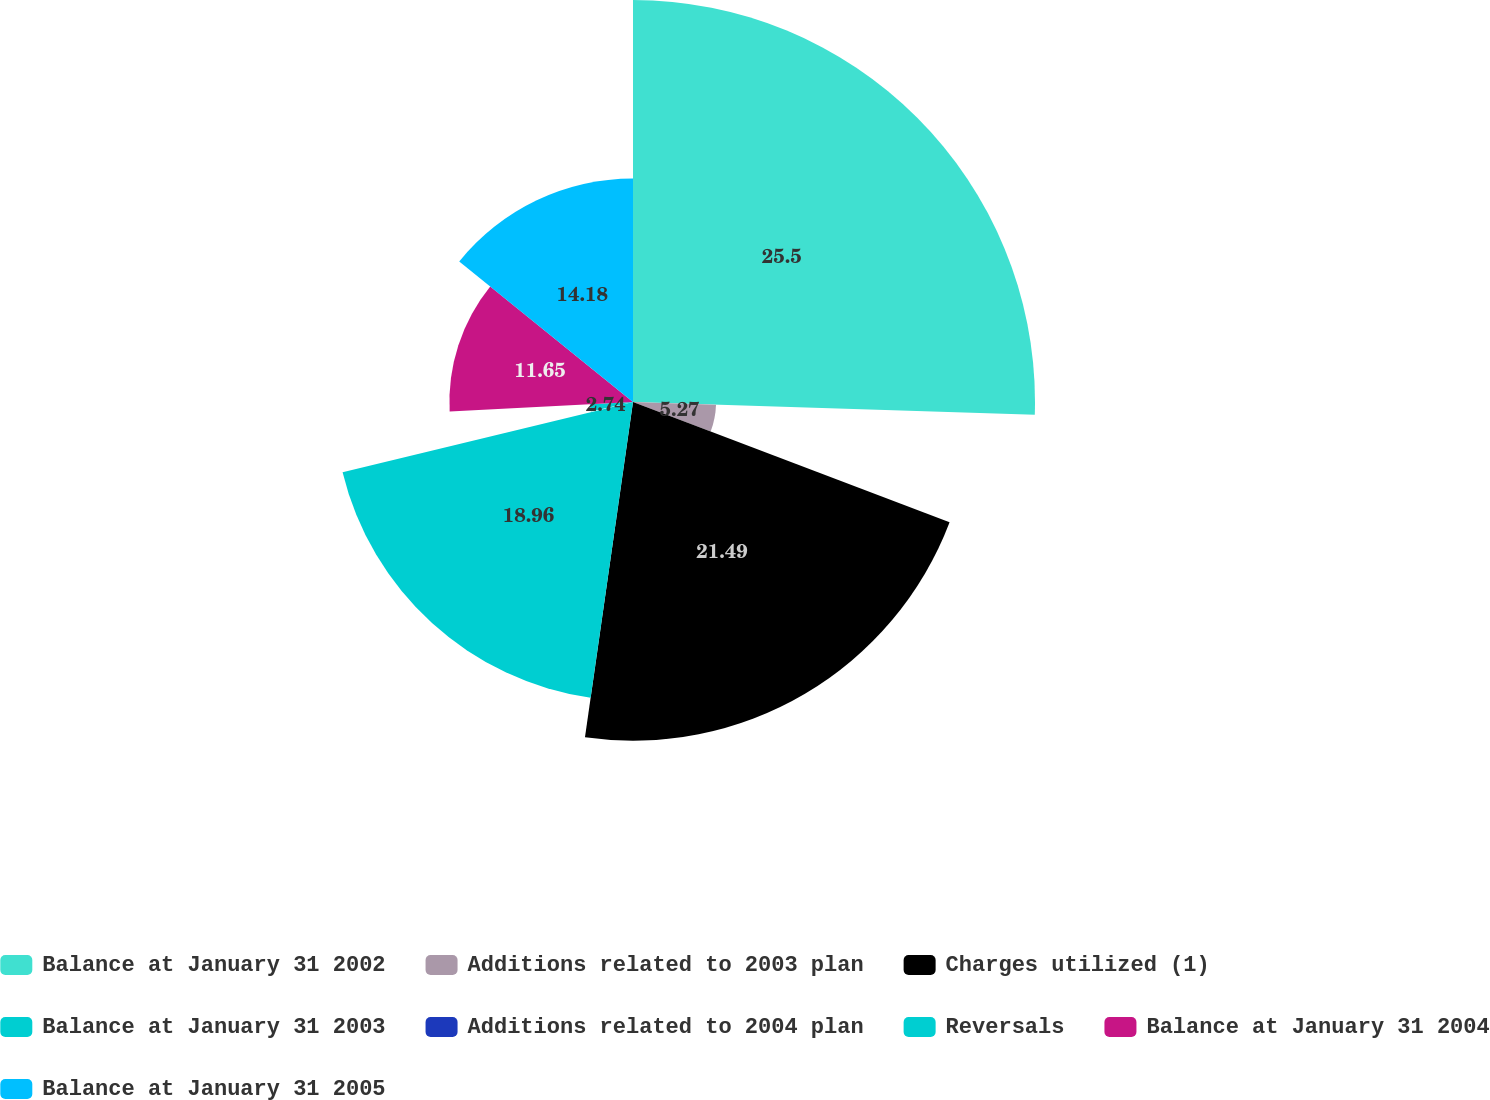<chart> <loc_0><loc_0><loc_500><loc_500><pie_chart><fcel>Balance at January 31 2002<fcel>Additions related to 2003 plan<fcel>Charges utilized (1)<fcel>Balance at January 31 2003<fcel>Additions related to 2004 plan<fcel>Reversals<fcel>Balance at January 31 2004<fcel>Balance at January 31 2005<nl><fcel>25.51%<fcel>5.27%<fcel>21.49%<fcel>18.96%<fcel>0.21%<fcel>2.74%<fcel>11.65%<fcel>14.18%<nl></chart> 